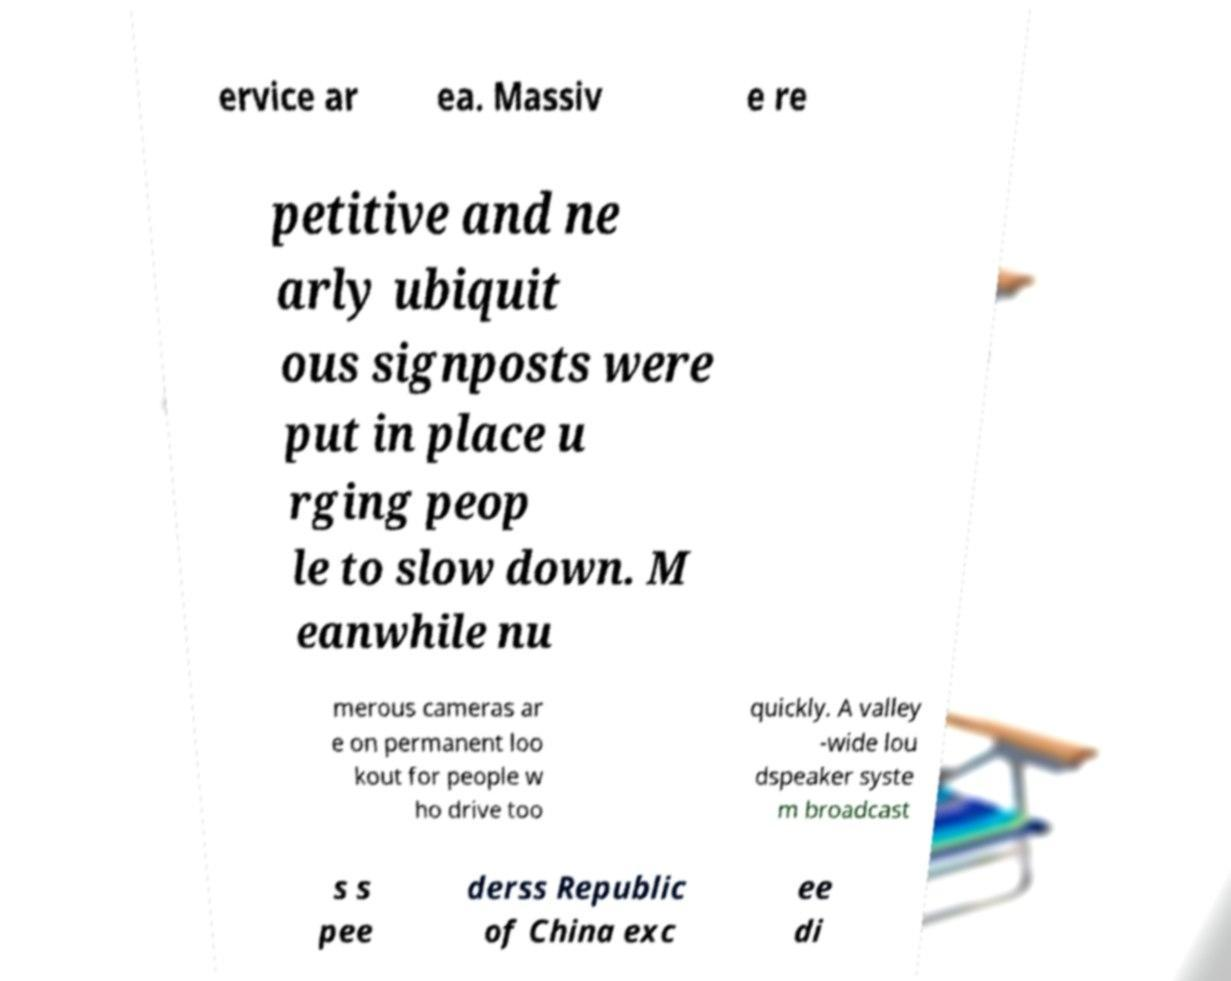Please identify and transcribe the text found in this image. ervice ar ea. Massiv e re petitive and ne arly ubiquit ous signposts were put in place u rging peop le to slow down. M eanwhile nu merous cameras ar e on permanent loo kout for people w ho drive too quickly. A valley -wide lou dspeaker syste m broadcast s s pee derss Republic of China exc ee di 